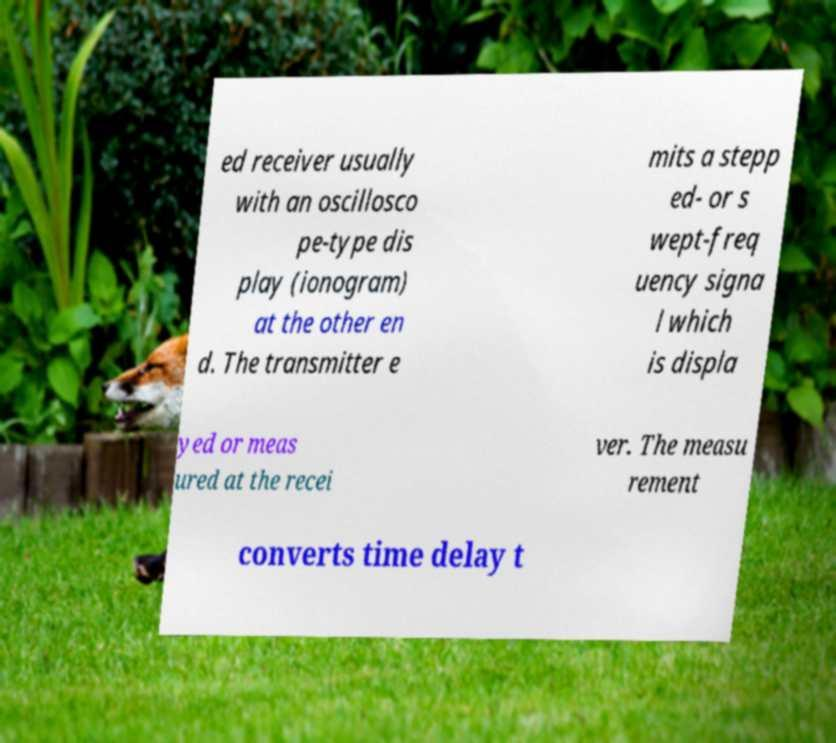Please identify and transcribe the text found in this image. ed receiver usually with an oscillosco pe-type dis play (ionogram) at the other en d. The transmitter e mits a stepp ed- or s wept-freq uency signa l which is displa yed or meas ured at the recei ver. The measu rement converts time delay t 